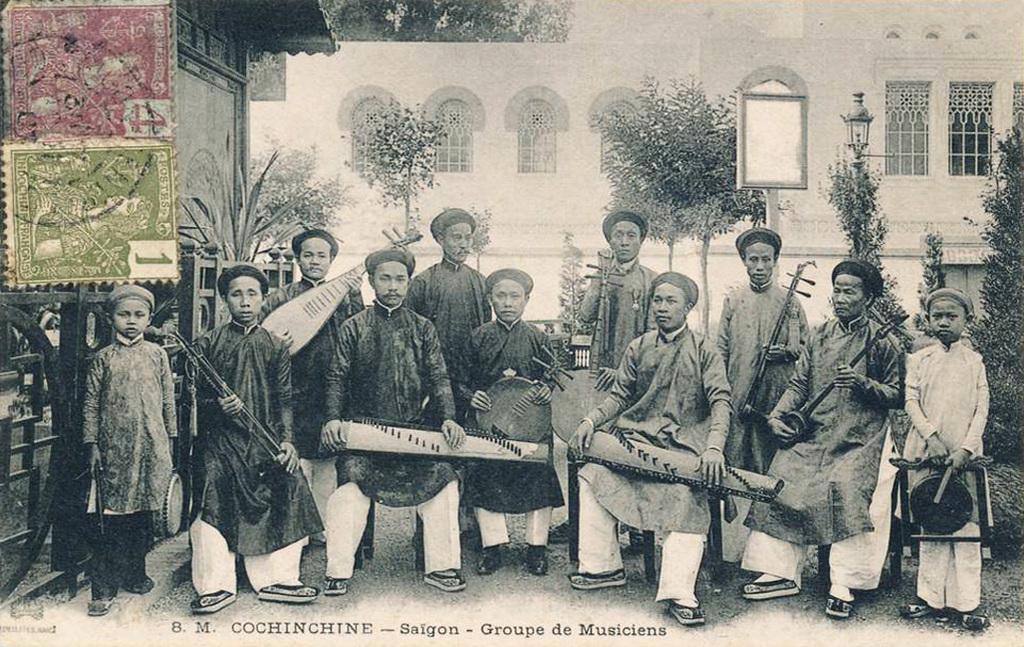In one or two sentences, can you explain what this image depicts? In this image we can see a group of people, in which few people are sitting on the chair and few people are standing. All the people in the image are holding musical instruments. There is a building and a house in the image. There are many plants and trees in the image. There are two postage stamps in the image. There is a gate in the image. 